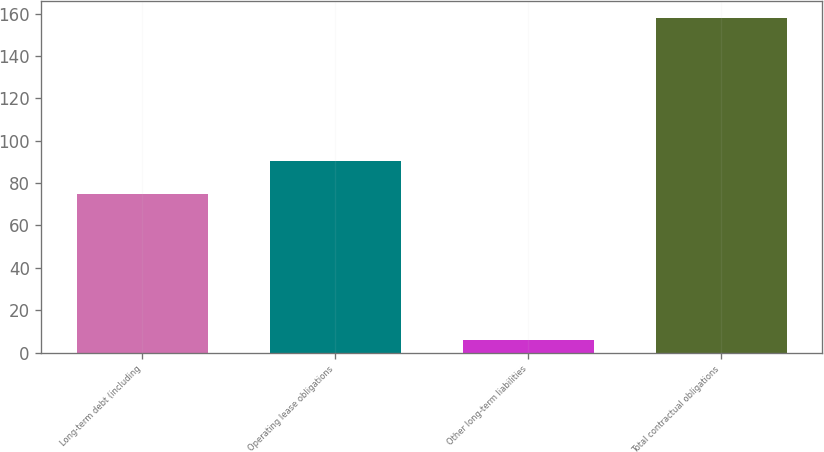<chart> <loc_0><loc_0><loc_500><loc_500><bar_chart><fcel>Long-term debt (including<fcel>Operating lease obligations<fcel>Other long-term liabilities<fcel>Total contractual obligations<nl><fcel>75<fcel>90.2<fcel>6<fcel>158<nl></chart> 